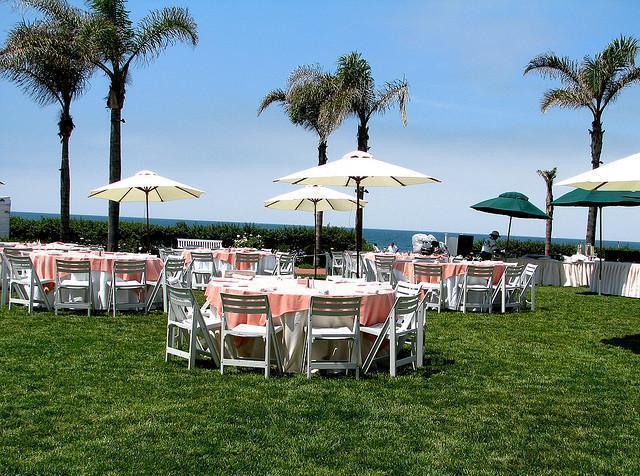What will be happening here in the very near future?
Choose the right answer and clarify with the format: 'Answer: answer
Rationale: rationale.'
Options: School class, church service, yacht sailing, large party. Answer: large party.
Rationale: Tables are set up outside with tablecloths and formal place settings. 